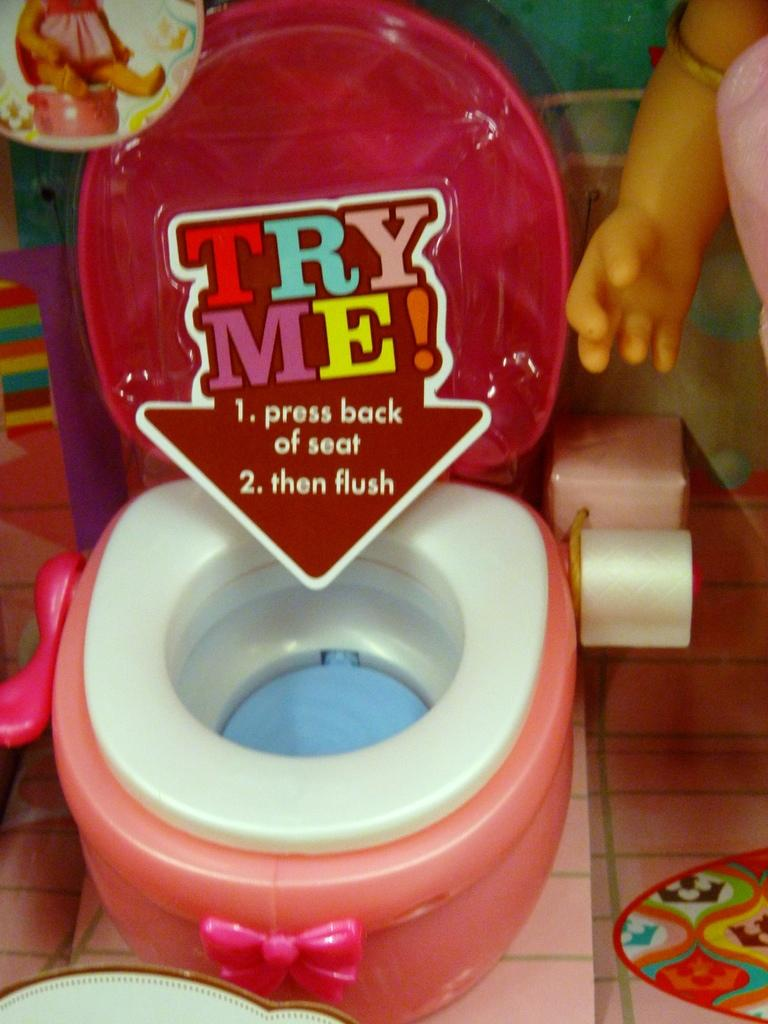What type of furniture is in the picture? There is a kids commode in the picture. What color is the commode? The commode is red in color. What else can be seen in the picture besides the commode? There are toys visible in the picture. Can you describe any additional details on the commode? There is a sticker with text on it in the picture. Is there a church visible in the picture? No, there is no church present in the image. 